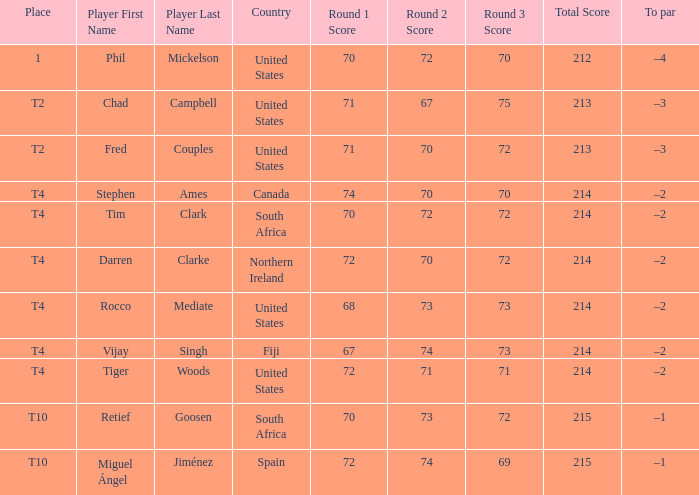How many points did spain achieve? 72-74-69=215. Would you be able to parse every entry in this table? {'header': ['Place', 'Player First Name', 'Player Last Name', 'Country', 'Round 1 Score', 'Round 2 Score', 'Round 3 Score', 'Total Score', 'To par'], 'rows': [['1', 'Phil', 'Mickelson', 'United States', '70', '72', '70', '212', '–4'], ['T2', 'Chad', 'Campbell', 'United States', '71', '67', '75', '213', '–3'], ['T2', 'Fred', 'Couples', 'United States', '71', '70', '72', '213', '–3'], ['T4', 'Stephen', 'Ames', 'Canada', '74', '70', '70', '214', '–2'], ['T4', 'Tim', 'Clark', 'South Africa', '70', '72', '72', '214', '–2'], ['T4', 'Darren', 'Clarke', 'Northern Ireland', '72', '70', '72', '214', '–2'], ['T4', 'Rocco', 'Mediate', 'United States', '68', '73', '73', '214', '–2'], ['T4', 'Vijay', 'Singh', 'Fiji', '67', '74', '73', '214', '–2'], ['T4', 'Tiger', 'Woods', 'United States', '72', '71', '71', '214', '–2'], ['T10', 'Retief', 'Goosen', 'South Africa', '70', '73', '72', '215', '–1'], ['T10', 'Miguel Ángel', 'Jiménez', 'Spain', '72', '74', '69', '215', '–1']]} 